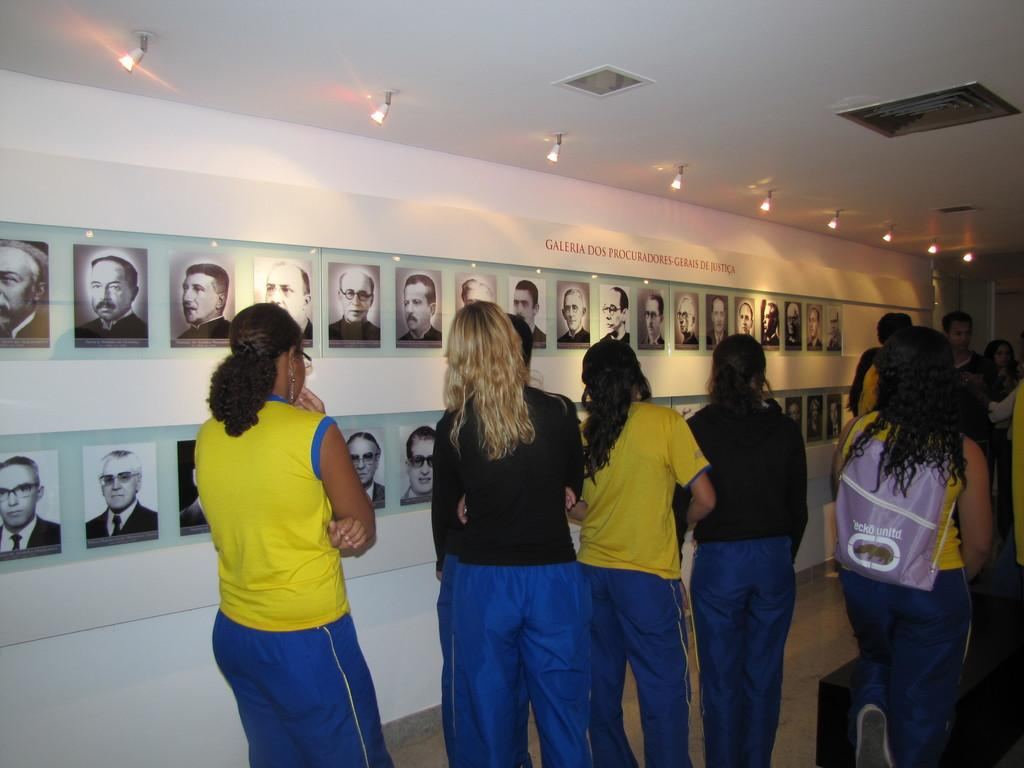What is happening in the image? There are people standing in the image. What can be seen on the wall in the image? There are pictures of people on the wall. What is located at the top of the image? There are lights at the top of the image. What type of pear can be seen being flexed by a muscle in the image? There is no pear or muscle present in the image. 